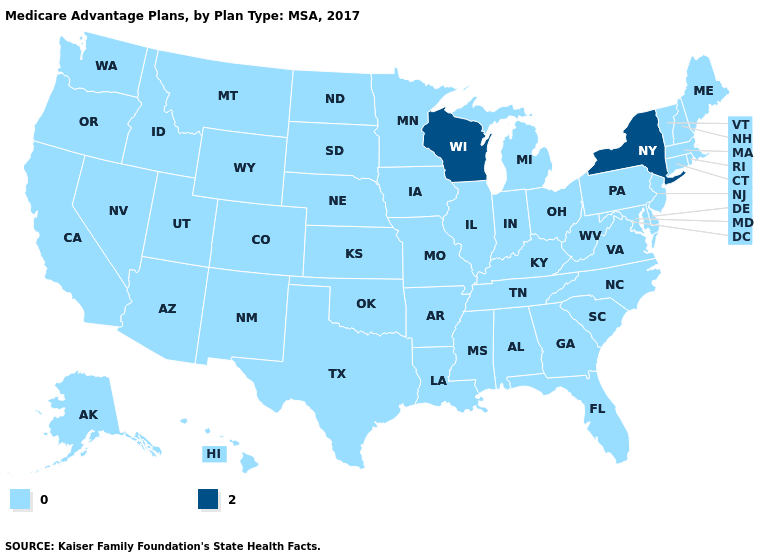Name the states that have a value in the range 2?
Be succinct. New York, Wisconsin. Which states have the lowest value in the USA?
Answer briefly. Alaska, Alabama, Arkansas, Arizona, California, Colorado, Connecticut, Delaware, Florida, Georgia, Hawaii, Iowa, Idaho, Illinois, Indiana, Kansas, Kentucky, Louisiana, Massachusetts, Maryland, Maine, Michigan, Minnesota, Missouri, Mississippi, Montana, North Carolina, North Dakota, Nebraska, New Hampshire, New Jersey, New Mexico, Nevada, Ohio, Oklahoma, Oregon, Pennsylvania, Rhode Island, South Carolina, South Dakota, Tennessee, Texas, Utah, Virginia, Vermont, Washington, West Virginia, Wyoming. What is the highest value in the USA?
Answer briefly. 2. What is the lowest value in the USA?
Short answer required. 0. Which states have the lowest value in the South?
Short answer required. Alabama, Arkansas, Delaware, Florida, Georgia, Kentucky, Louisiana, Maryland, Mississippi, North Carolina, Oklahoma, South Carolina, Tennessee, Texas, Virginia, West Virginia. What is the value of North Carolina?
Keep it brief. 0. Does Indiana have the same value as New York?
Short answer required. No. Does the map have missing data?
Concise answer only. No. Among the states that border Kentucky , which have the lowest value?
Give a very brief answer. Illinois, Indiana, Missouri, Ohio, Tennessee, Virginia, West Virginia. What is the highest value in states that border Virginia?
Short answer required. 0. Name the states that have a value in the range 2?
Write a very short answer. New York, Wisconsin. Name the states that have a value in the range 2?
Concise answer only. New York, Wisconsin. Does the first symbol in the legend represent the smallest category?
Keep it brief. Yes. Name the states that have a value in the range 0?
Quick response, please. Alaska, Alabama, Arkansas, Arizona, California, Colorado, Connecticut, Delaware, Florida, Georgia, Hawaii, Iowa, Idaho, Illinois, Indiana, Kansas, Kentucky, Louisiana, Massachusetts, Maryland, Maine, Michigan, Minnesota, Missouri, Mississippi, Montana, North Carolina, North Dakota, Nebraska, New Hampshire, New Jersey, New Mexico, Nevada, Ohio, Oklahoma, Oregon, Pennsylvania, Rhode Island, South Carolina, South Dakota, Tennessee, Texas, Utah, Virginia, Vermont, Washington, West Virginia, Wyoming. Which states have the highest value in the USA?
Give a very brief answer. New York, Wisconsin. 